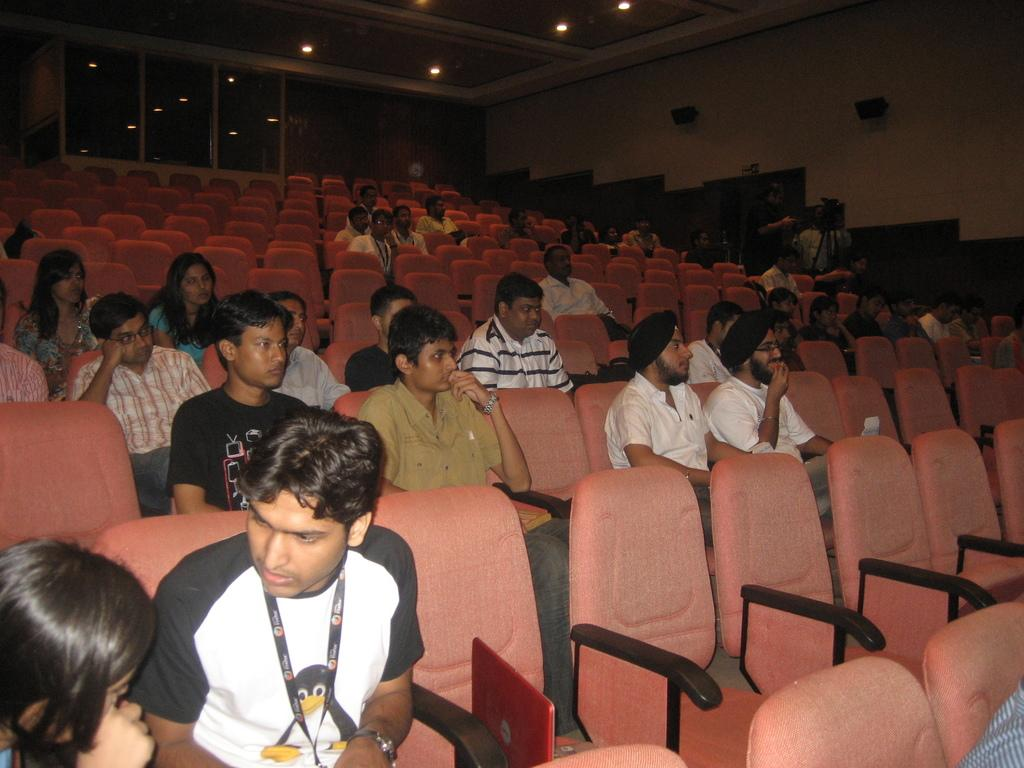How many people are in the image? There is a group of people in the image. What are the people doing in the image? The people are sitting on chairs. What color are the chairs? The chairs are brown. What can be seen in the background of the image? There is a wall, lights, and glass windows in the background of the image. What month is it in the image? The month cannot be determined from the image, as there is no information about the time of year. 